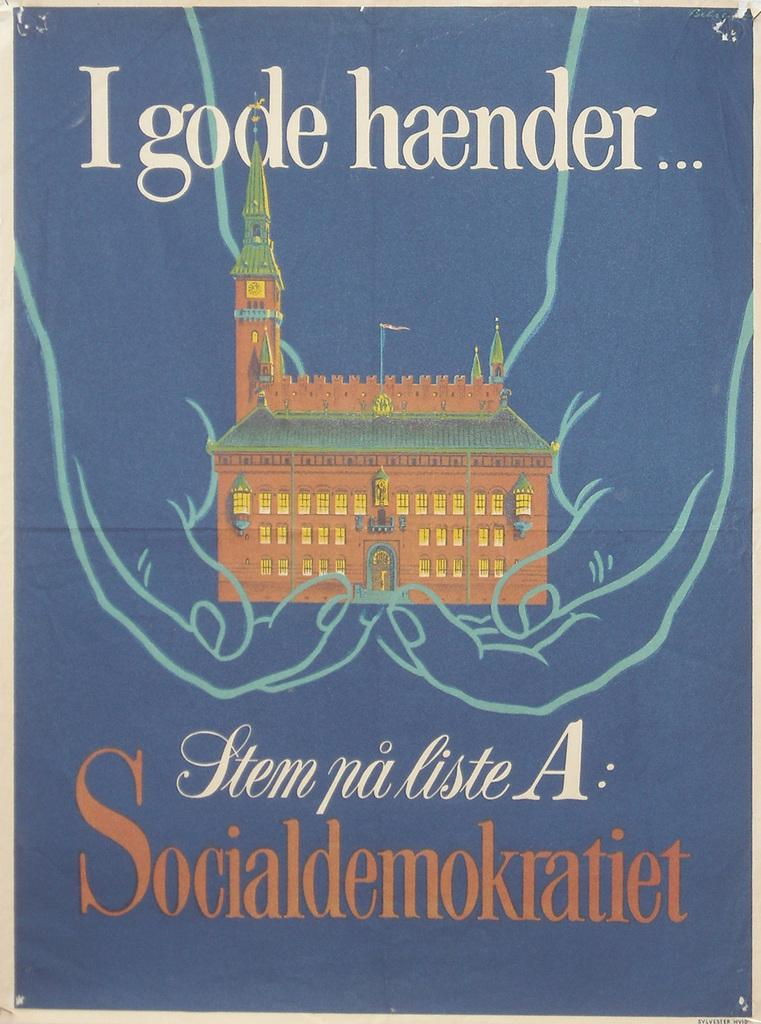<image>
Write a terse but informative summary of the picture. a blue poster that has the word Igode at the top and a church image too 